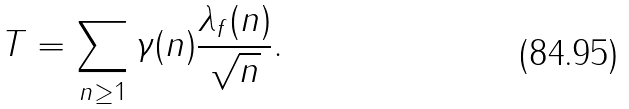Convert formula to latex. <formula><loc_0><loc_0><loc_500><loc_500>T = \sum _ { n \geq 1 } \gamma ( n ) \frac { \lambda _ { f } ( n ) } { \sqrt { n } } .</formula> 